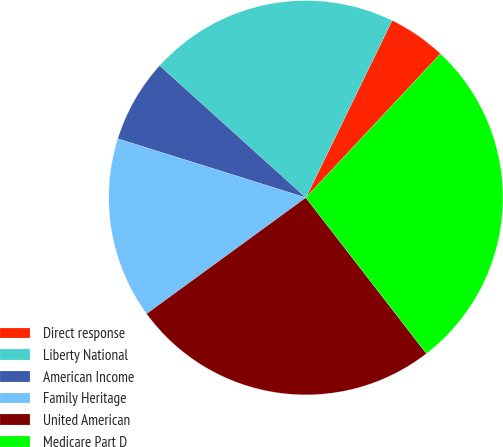<chart> <loc_0><loc_0><loc_500><loc_500><pie_chart><fcel>Direct response<fcel>Liberty National<fcel>American Income<fcel>Family Heritage<fcel>United American<fcel>Medicare Part D<nl><fcel>4.76%<fcel>20.52%<fcel>6.86%<fcel>14.86%<fcel>25.45%<fcel>27.55%<nl></chart> 